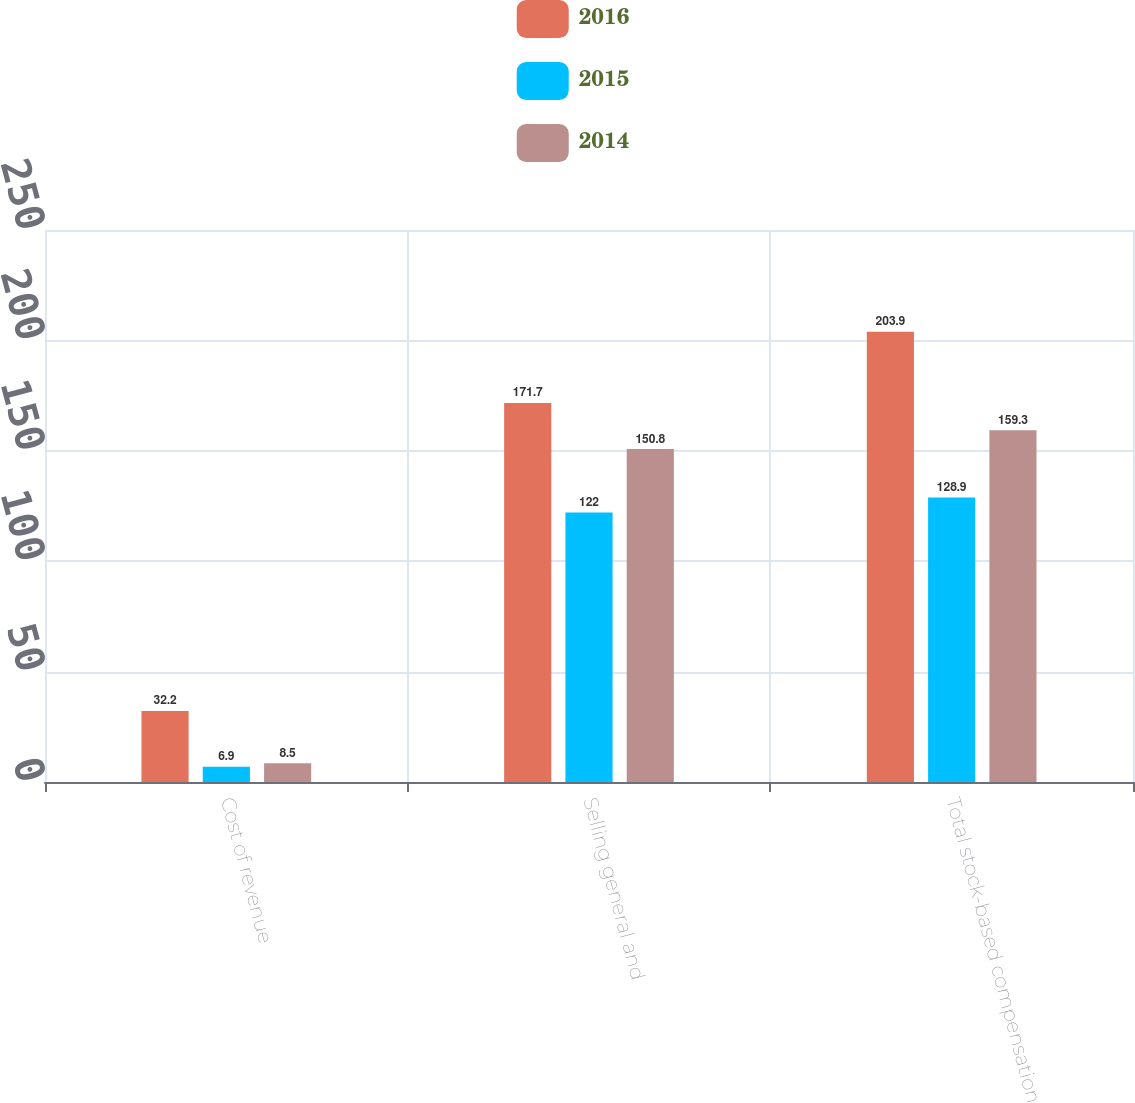Convert chart. <chart><loc_0><loc_0><loc_500><loc_500><stacked_bar_chart><ecel><fcel>Cost of revenue<fcel>Selling general and<fcel>Total stock-based compensation<nl><fcel>2016<fcel>32.2<fcel>171.7<fcel>203.9<nl><fcel>2015<fcel>6.9<fcel>122<fcel>128.9<nl><fcel>2014<fcel>8.5<fcel>150.8<fcel>159.3<nl></chart> 